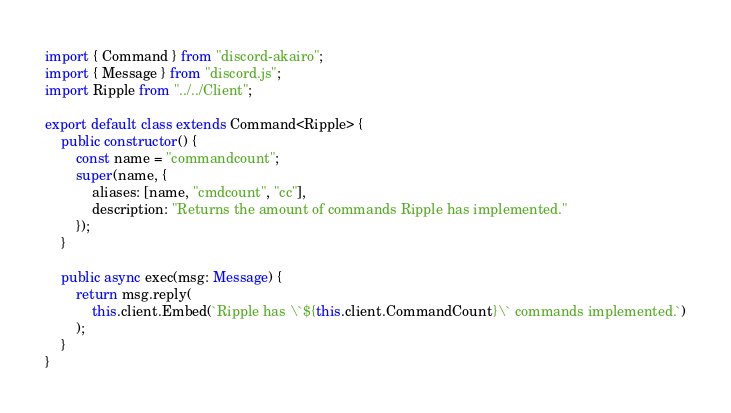<code> <loc_0><loc_0><loc_500><loc_500><_TypeScript_>import { Command } from "discord-akairo";
import { Message } from "discord.js";
import Ripple from "../../Client";

export default class extends Command<Ripple> {
    public constructor() {
        const name = "commandcount";
        super(name, {
            aliases: [name, "cmdcount", "cc"],
            description: "Returns the amount of commands Ripple has implemented."
        });
    }

    public async exec(msg: Message) {
        return msg.reply(
            this.client.Embed(`Ripple has \`${this.client.CommandCount}\` commands implemented.`)
        );
    }
}</code> 